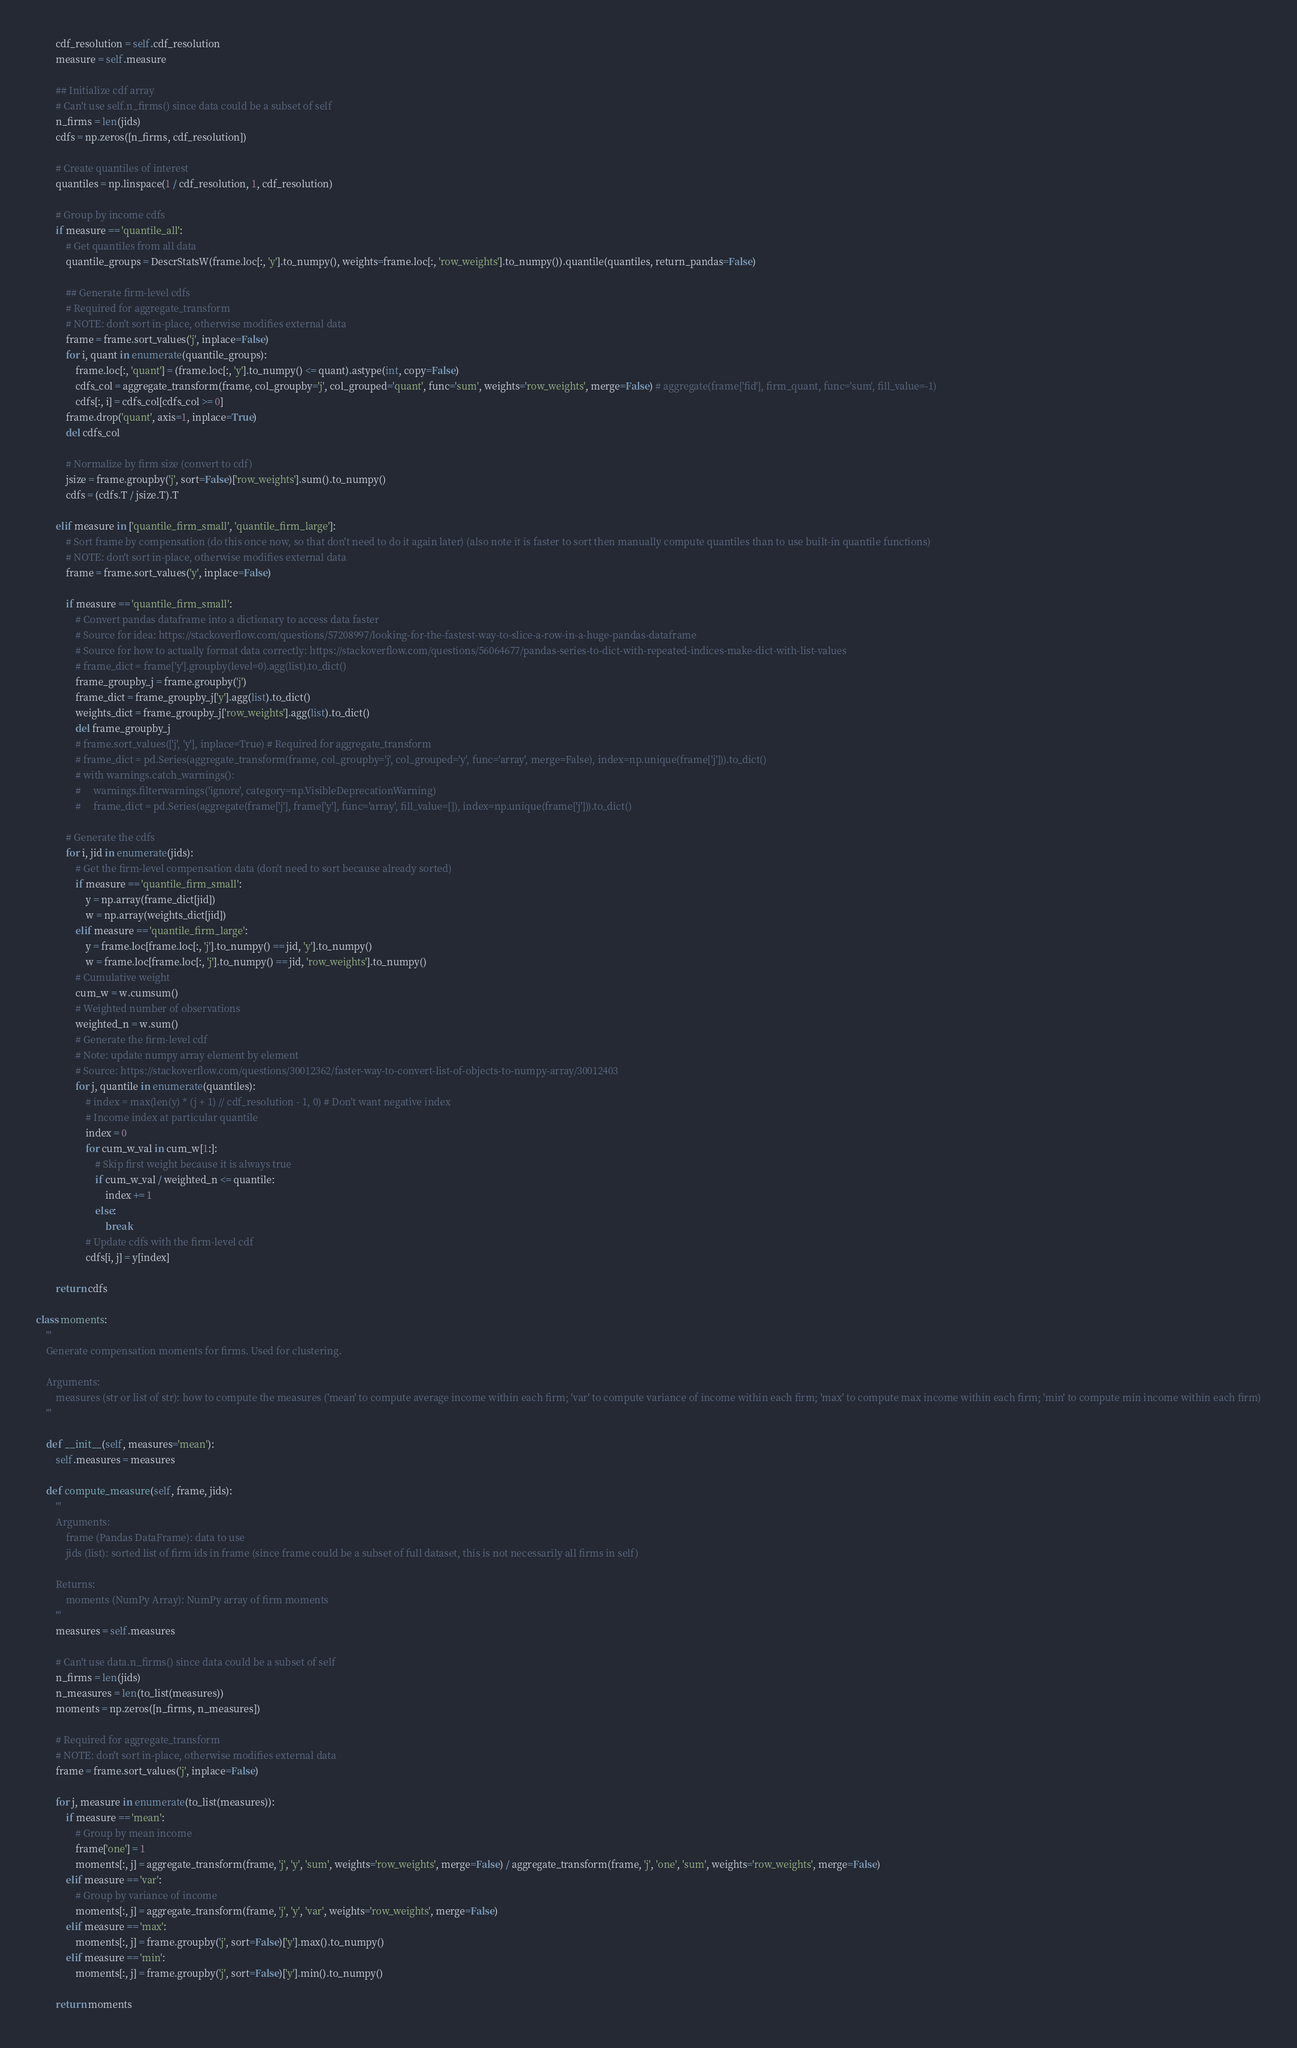Convert code to text. <code><loc_0><loc_0><loc_500><loc_500><_Python_>        cdf_resolution = self.cdf_resolution
        measure = self.measure

        ## Initialize cdf array
        # Can't use self.n_firms() since data could be a subset of self
        n_firms = len(jids)
        cdfs = np.zeros([n_firms, cdf_resolution])

        # Create quantiles of interest
        quantiles = np.linspace(1 / cdf_resolution, 1, cdf_resolution)

        # Group by income cdfs
        if measure == 'quantile_all':
            # Get quantiles from all data
            quantile_groups = DescrStatsW(frame.loc[:, 'y'].to_numpy(), weights=frame.loc[:, 'row_weights'].to_numpy()).quantile(quantiles, return_pandas=False)

            ## Generate firm-level cdfs
            # Required for aggregate_transform
            # NOTE: don't sort in-place, otherwise modifies external data
            frame = frame.sort_values('j', inplace=False)
            for i, quant in enumerate(quantile_groups):
                frame.loc[:, 'quant'] = (frame.loc[:, 'y'].to_numpy() <= quant).astype(int, copy=False)
                cdfs_col = aggregate_transform(frame, col_groupby='j', col_grouped='quant', func='sum', weights='row_weights', merge=False) # aggregate(frame['fid'], firm_quant, func='sum', fill_value=-1)
                cdfs[:, i] = cdfs_col[cdfs_col >= 0]
            frame.drop('quant', axis=1, inplace=True)
            del cdfs_col

            # Normalize by firm size (convert to cdf)
            jsize = frame.groupby('j', sort=False)['row_weights'].sum().to_numpy()
            cdfs = (cdfs.T / jsize.T).T

        elif measure in ['quantile_firm_small', 'quantile_firm_large']:
            # Sort frame by compensation (do this once now, so that don't need to do it again later) (also note it is faster to sort then manually compute quantiles than to use built-in quantile functions)
            # NOTE: don't sort in-place, otherwise modifies external data
            frame = frame.sort_values('y', inplace=False)

            if measure == 'quantile_firm_small':
                # Convert pandas dataframe into a dictionary to access data faster
                # Source for idea: https://stackoverflow.com/questions/57208997/looking-for-the-fastest-way-to-slice-a-row-in-a-huge-pandas-dataframe
                # Source for how to actually format data correctly: https://stackoverflow.com/questions/56064677/pandas-series-to-dict-with-repeated-indices-make-dict-with-list-values
                # frame_dict = frame['y'].groupby(level=0).agg(list).to_dict()
                frame_groupby_j = frame.groupby('j')
                frame_dict = frame_groupby_j['y'].agg(list).to_dict()
                weights_dict = frame_groupby_j['row_weights'].agg(list).to_dict()
                del frame_groupby_j
                # frame.sort_values(['j', 'y'], inplace=True) # Required for aggregate_transform
                # frame_dict = pd.Series(aggregate_transform(frame, col_groupby='j', col_grouped='y', func='array', merge=False), index=np.unique(frame['j'])).to_dict()
                # with warnings.catch_warnings():
                #     warnings.filterwarnings('ignore', category=np.VisibleDeprecationWarning)
                #     frame_dict = pd.Series(aggregate(frame['j'], frame['y'], func='array', fill_value=[]), index=np.unique(frame['j'])).to_dict()

            # Generate the cdfs
            for i, jid in enumerate(jids):
                # Get the firm-level compensation data (don't need to sort because already sorted)
                if measure == 'quantile_firm_small':
                    y = np.array(frame_dict[jid])
                    w = np.array(weights_dict[jid])
                elif measure == 'quantile_firm_large':
                    y = frame.loc[frame.loc[:, 'j'].to_numpy() == jid, 'y'].to_numpy()
                    w = frame.loc[frame.loc[:, 'j'].to_numpy() == jid, 'row_weights'].to_numpy()
                # Cumulative weight
                cum_w = w.cumsum()
                # Weighted number of observations
                weighted_n = w.sum()
                # Generate the firm-level cdf
                # Note: update numpy array element by element
                # Source: https://stackoverflow.com/questions/30012362/faster-way-to-convert-list-of-objects-to-numpy-array/30012403
                for j, quantile in enumerate(quantiles):
                    # index = max(len(y) * (j + 1) // cdf_resolution - 1, 0) # Don't want negative index
                    # Income index at particular quantile
                    index = 0
                    for cum_w_val in cum_w[1:]:
                        # Skip first weight because it is always true
                        if cum_w_val / weighted_n <= quantile:
                            index += 1
                        else:
                            break
                    # Update cdfs with the firm-level cdf
                    cdfs[i, j] = y[index]

        return cdfs

class moments:
    '''
    Generate compensation moments for firms. Used for clustering.

    Arguments:
        measures (str or list of str): how to compute the measures ('mean' to compute average income within each firm; 'var' to compute variance of income within each firm; 'max' to compute max income within each firm; 'min' to compute min income within each firm)
    '''

    def __init__(self, measures='mean'):
        self.measures = measures

    def compute_measure(self, frame, jids):
        '''
        Arguments:
            frame (Pandas DataFrame): data to use
            jids (list): sorted list of firm ids in frame (since frame could be a subset of full dataset, this is not necessarily all firms in self)

        Returns:
            moments (NumPy Array): NumPy array of firm moments
        '''
        measures = self.measures

        # Can't use data.n_firms() since data could be a subset of self
        n_firms = len(jids)
        n_measures = len(to_list(measures))
        moments = np.zeros([n_firms, n_measures])

        # Required for aggregate_transform
        # NOTE: don't sort in-place, otherwise modifies external data
        frame = frame.sort_values('j', inplace=False)

        for j, measure in enumerate(to_list(measures)):
            if measure == 'mean':
                # Group by mean income
                frame['one'] = 1
                moments[:, j] = aggregate_transform(frame, 'j', 'y', 'sum', weights='row_weights', merge=False) / aggregate_transform(frame, 'j', 'one', 'sum', weights='row_weights', merge=False)
            elif measure == 'var':
                # Group by variance of income
                moments[:, j] = aggregate_transform(frame, 'j', 'y', 'var', weights='row_weights', merge=False)
            elif measure == 'max':
                moments[:, j] = frame.groupby('j', sort=False)['y'].max().to_numpy()
            elif measure == 'min':
                moments[:, j] = frame.groupby('j', sort=False)['y'].min().to_numpy()

        return moments
</code> 